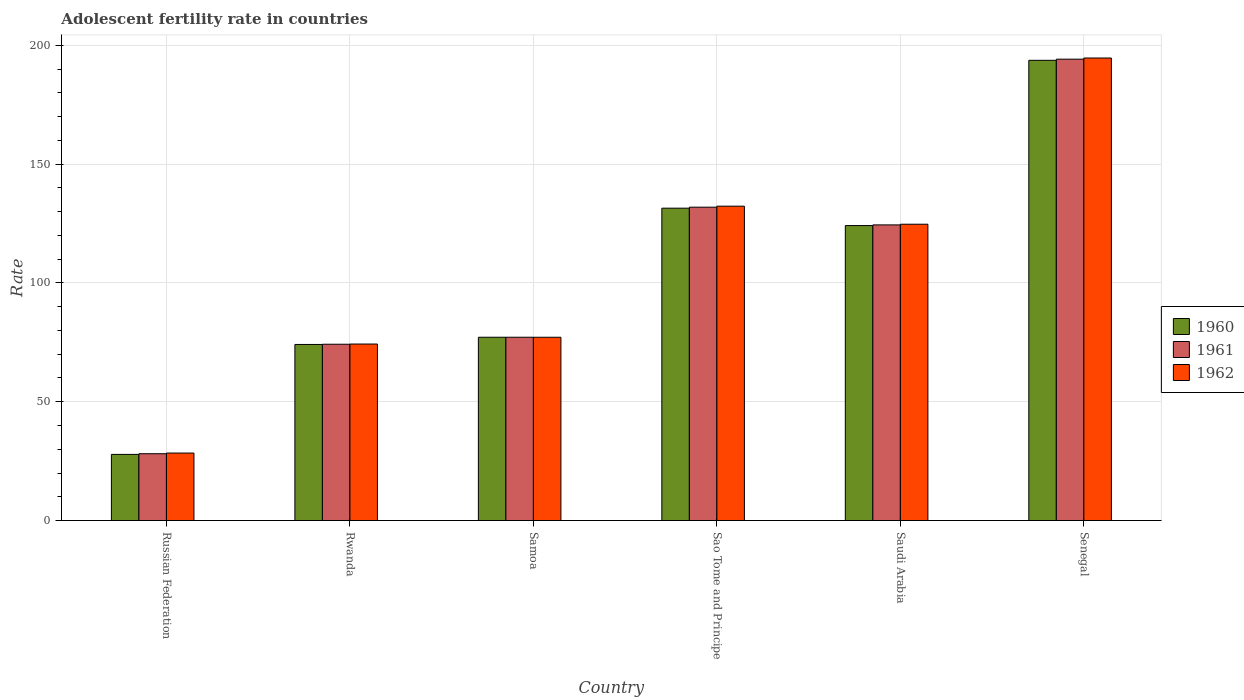How many different coloured bars are there?
Offer a very short reply. 3. Are the number of bars per tick equal to the number of legend labels?
Offer a terse response. Yes. What is the label of the 2nd group of bars from the left?
Give a very brief answer. Rwanda. In how many cases, is the number of bars for a given country not equal to the number of legend labels?
Make the answer very short. 0. What is the adolescent fertility rate in 1961 in Russian Federation?
Provide a short and direct response. 28.13. Across all countries, what is the maximum adolescent fertility rate in 1960?
Provide a succinct answer. 193.68. Across all countries, what is the minimum adolescent fertility rate in 1960?
Your answer should be compact. 27.85. In which country was the adolescent fertility rate in 1961 maximum?
Your response must be concise. Senegal. In which country was the adolescent fertility rate in 1960 minimum?
Provide a short and direct response. Russian Federation. What is the total adolescent fertility rate in 1960 in the graph?
Your answer should be very brief. 628.39. What is the difference between the adolescent fertility rate in 1962 in Samoa and that in Senegal?
Offer a very short reply. -117.51. What is the difference between the adolescent fertility rate in 1961 in Sao Tome and Principe and the adolescent fertility rate in 1960 in Saudi Arabia?
Ensure brevity in your answer.  7.74. What is the average adolescent fertility rate in 1960 per country?
Your answer should be very brief. 104.73. What is the difference between the adolescent fertility rate of/in 1961 and adolescent fertility rate of/in 1960 in Senegal?
Ensure brevity in your answer.  0.49. What is the ratio of the adolescent fertility rate in 1961 in Russian Federation to that in Samoa?
Give a very brief answer. 0.36. Is the adolescent fertility rate in 1960 in Sao Tome and Principe less than that in Senegal?
Keep it short and to the point. Yes. Is the difference between the adolescent fertility rate in 1961 in Russian Federation and Senegal greater than the difference between the adolescent fertility rate in 1960 in Russian Federation and Senegal?
Ensure brevity in your answer.  No. What is the difference between the highest and the second highest adolescent fertility rate in 1960?
Make the answer very short. 62.22. What is the difference between the highest and the lowest adolescent fertility rate in 1961?
Give a very brief answer. 166.03. What does the 3rd bar from the left in Saudi Arabia represents?
Your response must be concise. 1962. How many bars are there?
Provide a succinct answer. 18. How many countries are there in the graph?
Offer a terse response. 6. What is the difference between two consecutive major ticks on the Y-axis?
Your answer should be very brief. 50. Does the graph contain any zero values?
Your answer should be very brief. No. Where does the legend appear in the graph?
Your response must be concise. Center right. How are the legend labels stacked?
Your answer should be compact. Vertical. What is the title of the graph?
Your response must be concise. Adolescent fertility rate in countries. Does "1974" appear as one of the legend labels in the graph?
Give a very brief answer. No. What is the label or title of the X-axis?
Your answer should be very brief. Country. What is the label or title of the Y-axis?
Make the answer very short. Rate. What is the Rate of 1960 in Russian Federation?
Offer a very short reply. 27.85. What is the Rate in 1961 in Russian Federation?
Offer a terse response. 28.13. What is the Rate in 1962 in Russian Federation?
Your answer should be compact. 28.42. What is the Rate of 1960 in Rwanda?
Ensure brevity in your answer.  74.11. What is the Rate in 1961 in Rwanda?
Provide a short and direct response. 74.2. What is the Rate of 1962 in Rwanda?
Make the answer very short. 74.29. What is the Rate in 1960 in Samoa?
Offer a very short reply. 77.15. What is the Rate of 1961 in Samoa?
Your answer should be very brief. 77.15. What is the Rate of 1962 in Samoa?
Offer a terse response. 77.14. What is the Rate in 1960 in Sao Tome and Principe?
Your response must be concise. 131.46. What is the Rate in 1961 in Sao Tome and Principe?
Your response must be concise. 131.88. What is the Rate in 1962 in Sao Tome and Principe?
Offer a terse response. 132.3. What is the Rate of 1960 in Saudi Arabia?
Ensure brevity in your answer.  124.14. What is the Rate of 1961 in Saudi Arabia?
Your answer should be very brief. 124.42. What is the Rate of 1962 in Saudi Arabia?
Your answer should be very brief. 124.7. What is the Rate of 1960 in Senegal?
Your response must be concise. 193.68. What is the Rate in 1961 in Senegal?
Your response must be concise. 194.17. What is the Rate of 1962 in Senegal?
Give a very brief answer. 194.66. Across all countries, what is the maximum Rate of 1960?
Offer a terse response. 193.68. Across all countries, what is the maximum Rate of 1961?
Keep it short and to the point. 194.17. Across all countries, what is the maximum Rate of 1962?
Make the answer very short. 194.66. Across all countries, what is the minimum Rate in 1960?
Provide a succinct answer. 27.85. Across all countries, what is the minimum Rate in 1961?
Your answer should be compact. 28.13. Across all countries, what is the minimum Rate in 1962?
Your answer should be compact. 28.42. What is the total Rate of 1960 in the graph?
Make the answer very short. 628.39. What is the total Rate of 1961 in the graph?
Offer a terse response. 629.95. What is the total Rate in 1962 in the graph?
Give a very brief answer. 631.51. What is the difference between the Rate of 1960 in Russian Federation and that in Rwanda?
Ensure brevity in your answer.  -46.26. What is the difference between the Rate of 1961 in Russian Federation and that in Rwanda?
Your response must be concise. -46.07. What is the difference between the Rate in 1962 in Russian Federation and that in Rwanda?
Offer a very short reply. -45.88. What is the difference between the Rate of 1960 in Russian Federation and that in Samoa?
Your response must be concise. -49.3. What is the difference between the Rate in 1961 in Russian Federation and that in Samoa?
Offer a terse response. -49.01. What is the difference between the Rate in 1962 in Russian Federation and that in Samoa?
Offer a very short reply. -48.73. What is the difference between the Rate of 1960 in Russian Federation and that in Sao Tome and Principe?
Your answer should be compact. -103.61. What is the difference between the Rate in 1961 in Russian Federation and that in Sao Tome and Principe?
Provide a short and direct response. -103.75. What is the difference between the Rate of 1962 in Russian Federation and that in Sao Tome and Principe?
Provide a succinct answer. -103.88. What is the difference between the Rate in 1960 in Russian Federation and that in Saudi Arabia?
Offer a very short reply. -96.29. What is the difference between the Rate in 1961 in Russian Federation and that in Saudi Arabia?
Your answer should be compact. -96.29. What is the difference between the Rate of 1962 in Russian Federation and that in Saudi Arabia?
Offer a terse response. -96.29. What is the difference between the Rate in 1960 in Russian Federation and that in Senegal?
Keep it short and to the point. -165.83. What is the difference between the Rate of 1961 in Russian Federation and that in Senegal?
Offer a very short reply. -166.03. What is the difference between the Rate in 1962 in Russian Federation and that in Senegal?
Ensure brevity in your answer.  -166.24. What is the difference between the Rate in 1960 in Rwanda and that in Samoa?
Ensure brevity in your answer.  -3.04. What is the difference between the Rate in 1961 in Rwanda and that in Samoa?
Your answer should be compact. -2.94. What is the difference between the Rate of 1962 in Rwanda and that in Samoa?
Give a very brief answer. -2.85. What is the difference between the Rate of 1960 in Rwanda and that in Sao Tome and Principe?
Keep it short and to the point. -57.35. What is the difference between the Rate in 1961 in Rwanda and that in Sao Tome and Principe?
Your answer should be very brief. -57.68. What is the difference between the Rate of 1962 in Rwanda and that in Sao Tome and Principe?
Make the answer very short. -58.01. What is the difference between the Rate of 1960 in Rwanda and that in Saudi Arabia?
Offer a very short reply. -50.03. What is the difference between the Rate in 1961 in Rwanda and that in Saudi Arabia?
Give a very brief answer. -50.22. What is the difference between the Rate of 1962 in Rwanda and that in Saudi Arabia?
Provide a short and direct response. -50.41. What is the difference between the Rate in 1960 in Rwanda and that in Senegal?
Give a very brief answer. -119.57. What is the difference between the Rate of 1961 in Rwanda and that in Senegal?
Provide a short and direct response. -119.97. What is the difference between the Rate in 1962 in Rwanda and that in Senegal?
Provide a short and direct response. -120.36. What is the difference between the Rate in 1960 in Samoa and that in Sao Tome and Principe?
Offer a very short reply. -54.31. What is the difference between the Rate of 1961 in Samoa and that in Sao Tome and Principe?
Provide a succinct answer. -54.73. What is the difference between the Rate of 1962 in Samoa and that in Sao Tome and Principe?
Your answer should be compact. -55.16. What is the difference between the Rate in 1960 in Samoa and that in Saudi Arabia?
Your response must be concise. -46.99. What is the difference between the Rate in 1961 in Samoa and that in Saudi Arabia?
Keep it short and to the point. -47.28. What is the difference between the Rate of 1962 in Samoa and that in Saudi Arabia?
Keep it short and to the point. -47.56. What is the difference between the Rate of 1960 in Samoa and that in Senegal?
Keep it short and to the point. -116.53. What is the difference between the Rate of 1961 in Samoa and that in Senegal?
Keep it short and to the point. -117.02. What is the difference between the Rate in 1962 in Samoa and that in Senegal?
Make the answer very short. -117.51. What is the difference between the Rate of 1960 in Sao Tome and Principe and that in Saudi Arabia?
Give a very brief answer. 7.32. What is the difference between the Rate of 1961 in Sao Tome and Principe and that in Saudi Arabia?
Your answer should be very brief. 7.46. What is the difference between the Rate of 1962 in Sao Tome and Principe and that in Saudi Arabia?
Your answer should be compact. 7.6. What is the difference between the Rate of 1960 in Sao Tome and Principe and that in Senegal?
Your answer should be compact. -62.22. What is the difference between the Rate in 1961 in Sao Tome and Principe and that in Senegal?
Ensure brevity in your answer.  -62.29. What is the difference between the Rate of 1962 in Sao Tome and Principe and that in Senegal?
Ensure brevity in your answer.  -62.35. What is the difference between the Rate in 1960 in Saudi Arabia and that in Senegal?
Your answer should be compact. -69.54. What is the difference between the Rate of 1961 in Saudi Arabia and that in Senegal?
Provide a short and direct response. -69.75. What is the difference between the Rate in 1962 in Saudi Arabia and that in Senegal?
Offer a terse response. -69.95. What is the difference between the Rate in 1960 in Russian Federation and the Rate in 1961 in Rwanda?
Keep it short and to the point. -46.35. What is the difference between the Rate in 1960 in Russian Federation and the Rate in 1962 in Rwanda?
Provide a succinct answer. -46.44. What is the difference between the Rate in 1961 in Russian Federation and the Rate in 1962 in Rwanda?
Ensure brevity in your answer.  -46.16. What is the difference between the Rate of 1960 in Russian Federation and the Rate of 1961 in Samoa?
Make the answer very short. -49.29. What is the difference between the Rate in 1960 in Russian Federation and the Rate in 1962 in Samoa?
Make the answer very short. -49.29. What is the difference between the Rate in 1961 in Russian Federation and the Rate in 1962 in Samoa?
Your response must be concise. -49.01. What is the difference between the Rate in 1960 in Russian Federation and the Rate in 1961 in Sao Tome and Principe?
Offer a terse response. -104.03. What is the difference between the Rate of 1960 in Russian Federation and the Rate of 1962 in Sao Tome and Principe?
Offer a terse response. -104.45. What is the difference between the Rate in 1961 in Russian Federation and the Rate in 1962 in Sao Tome and Principe?
Provide a short and direct response. -104.17. What is the difference between the Rate in 1960 in Russian Federation and the Rate in 1961 in Saudi Arabia?
Your answer should be compact. -96.57. What is the difference between the Rate of 1960 in Russian Federation and the Rate of 1962 in Saudi Arabia?
Your response must be concise. -96.85. What is the difference between the Rate in 1961 in Russian Federation and the Rate in 1962 in Saudi Arabia?
Make the answer very short. -96.57. What is the difference between the Rate in 1960 in Russian Federation and the Rate in 1961 in Senegal?
Offer a terse response. -166.32. What is the difference between the Rate in 1960 in Russian Federation and the Rate in 1962 in Senegal?
Your response must be concise. -166.8. What is the difference between the Rate of 1961 in Russian Federation and the Rate of 1962 in Senegal?
Provide a short and direct response. -166.52. What is the difference between the Rate in 1960 in Rwanda and the Rate in 1961 in Samoa?
Keep it short and to the point. -3.04. What is the difference between the Rate of 1960 in Rwanda and the Rate of 1962 in Samoa?
Your answer should be very brief. -3.03. What is the difference between the Rate in 1961 in Rwanda and the Rate in 1962 in Samoa?
Your response must be concise. -2.94. What is the difference between the Rate in 1960 in Rwanda and the Rate in 1961 in Sao Tome and Principe?
Offer a very short reply. -57.77. What is the difference between the Rate of 1960 in Rwanda and the Rate of 1962 in Sao Tome and Principe?
Your answer should be very brief. -58.19. What is the difference between the Rate of 1961 in Rwanda and the Rate of 1962 in Sao Tome and Principe?
Your response must be concise. -58.1. What is the difference between the Rate in 1960 in Rwanda and the Rate in 1961 in Saudi Arabia?
Make the answer very short. -50.31. What is the difference between the Rate in 1960 in Rwanda and the Rate in 1962 in Saudi Arabia?
Provide a short and direct response. -50.59. What is the difference between the Rate in 1961 in Rwanda and the Rate in 1962 in Saudi Arabia?
Keep it short and to the point. -50.5. What is the difference between the Rate of 1960 in Rwanda and the Rate of 1961 in Senegal?
Your answer should be very brief. -120.06. What is the difference between the Rate of 1960 in Rwanda and the Rate of 1962 in Senegal?
Offer a terse response. -120.54. What is the difference between the Rate in 1961 in Rwanda and the Rate in 1962 in Senegal?
Your response must be concise. -120.45. What is the difference between the Rate of 1960 in Samoa and the Rate of 1961 in Sao Tome and Principe?
Your answer should be compact. -54.73. What is the difference between the Rate of 1960 in Samoa and the Rate of 1962 in Sao Tome and Principe?
Make the answer very short. -55.15. What is the difference between the Rate in 1961 in Samoa and the Rate in 1962 in Sao Tome and Principe?
Give a very brief answer. -55.15. What is the difference between the Rate of 1960 in Samoa and the Rate of 1961 in Saudi Arabia?
Make the answer very short. -47.27. What is the difference between the Rate of 1960 in Samoa and the Rate of 1962 in Saudi Arabia?
Ensure brevity in your answer.  -47.56. What is the difference between the Rate of 1961 in Samoa and the Rate of 1962 in Saudi Arabia?
Your answer should be compact. -47.56. What is the difference between the Rate in 1960 in Samoa and the Rate in 1961 in Senegal?
Provide a succinct answer. -117.02. What is the difference between the Rate in 1960 in Samoa and the Rate in 1962 in Senegal?
Your response must be concise. -117.51. What is the difference between the Rate in 1961 in Samoa and the Rate in 1962 in Senegal?
Ensure brevity in your answer.  -117.51. What is the difference between the Rate in 1960 in Sao Tome and Principe and the Rate in 1961 in Saudi Arabia?
Your answer should be compact. 7.04. What is the difference between the Rate of 1960 in Sao Tome and Principe and the Rate of 1962 in Saudi Arabia?
Offer a very short reply. 6.76. What is the difference between the Rate in 1961 in Sao Tome and Principe and the Rate in 1962 in Saudi Arabia?
Give a very brief answer. 7.18. What is the difference between the Rate in 1960 in Sao Tome and Principe and the Rate in 1961 in Senegal?
Offer a terse response. -62.71. What is the difference between the Rate in 1960 in Sao Tome and Principe and the Rate in 1962 in Senegal?
Provide a short and direct response. -63.2. What is the difference between the Rate in 1961 in Sao Tome and Principe and the Rate in 1962 in Senegal?
Your answer should be compact. -62.77. What is the difference between the Rate in 1960 in Saudi Arabia and the Rate in 1961 in Senegal?
Give a very brief answer. -70.03. What is the difference between the Rate in 1960 in Saudi Arabia and the Rate in 1962 in Senegal?
Your answer should be very brief. -70.51. What is the difference between the Rate of 1961 in Saudi Arabia and the Rate of 1962 in Senegal?
Provide a short and direct response. -70.23. What is the average Rate in 1960 per country?
Your response must be concise. 104.73. What is the average Rate of 1961 per country?
Keep it short and to the point. 104.99. What is the average Rate of 1962 per country?
Make the answer very short. 105.25. What is the difference between the Rate of 1960 and Rate of 1961 in Russian Federation?
Your response must be concise. -0.28. What is the difference between the Rate of 1960 and Rate of 1962 in Russian Federation?
Offer a very short reply. -0.57. What is the difference between the Rate of 1961 and Rate of 1962 in Russian Federation?
Your response must be concise. -0.28. What is the difference between the Rate in 1960 and Rate in 1961 in Rwanda?
Offer a very short reply. -0.09. What is the difference between the Rate in 1960 and Rate in 1962 in Rwanda?
Ensure brevity in your answer.  -0.18. What is the difference between the Rate in 1961 and Rate in 1962 in Rwanda?
Your answer should be very brief. -0.09. What is the difference between the Rate in 1960 and Rate in 1961 in Samoa?
Give a very brief answer. 0. What is the difference between the Rate in 1960 and Rate in 1962 in Samoa?
Provide a short and direct response. 0. What is the difference between the Rate in 1961 and Rate in 1962 in Samoa?
Offer a very short reply. 0. What is the difference between the Rate of 1960 and Rate of 1961 in Sao Tome and Principe?
Give a very brief answer. -0.42. What is the difference between the Rate in 1960 and Rate in 1962 in Sao Tome and Principe?
Your response must be concise. -0.84. What is the difference between the Rate in 1961 and Rate in 1962 in Sao Tome and Principe?
Offer a very short reply. -0.42. What is the difference between the Rate of 1960 and Rate of 1961 in Saudi Arabia?
Provide a short and direct response. -0.28. What is the difference between the Rate in 1960 and Rate in 1962 in Saudi Arabia?
Your response must be concise. -0.56. What is the difference between the Rate of 1961 and Rate of 1962 in Saudi Arabia?
Offer a very short reply. -0.28. What is the difference between the Rate of 1960 and Rate of 1961 in Senegal?
Give a very brief answer. -0.49. What is the difference between the Rate of 1960 and Rate of 1962 in Senegal?
Offer a very short reply. -0.97. What is the difference between the Rate in 1961 and Rate in 1962 in Senegal?
Offer a very short reply. -0.49. What is the ratio of the Rate in 1960 in Russian Federation to that in Rwanda?
Your response must be concise. 0.38. What is the ratio of the Rate of 1961 in Russian Federation to that in Rwanda?
Make the answer very short. 0.38. What is the ratio of the Rate in 1962 in Russian Federation to that in Rwanda?
Ensure brevity in your answer.  0.38. What is the ratio of the Rate in 1960 in Russian Federation to that in Samoa?
Ensure brevity in your answer.  0.36. What is the ratio of the Rate of 1961 in Russian Federation to that in Samoa?
Offer a terse response. 0.36. What is the ratio of the Rate in 1962 in Russian Federation to that in Samoa?
Your response must be concise. 0.37. What is the ratio of the Rate in 1960 in Russian Federation to that in Sao Tome and Principe?
Offer a terse response. 0.21. What is the ratio of the Rate of 1961 in Russian Federation to that in Sao Tome and Principe?
Your answer should be very brief. 0.21. What is the ratio of the Rate of 1962 in Russian Federation to that in Sao Tome and Principe?
Offer a terse response. 0.21. What is the ratio of the Rate of 1960 in Russian Federation to that in Saudi Arabia?
Provide a succinct answer. 0.22. What is the ratio of the Rate in 1961 in Russian Federation to that in Saudi Arabia?
Your answer should be compact. 0.23. What is the ratio of the Rate in 1962 in Russian Federation to that in Saudi Arabia?
Provide a succinct answer. 0.23. What is the ratio of the Rate in 1960 in Russian Federation to that in Senegal?
Offer a terse response. 0.14. What is the ratio of the Rate of 1961 in Russian Federation to that in Senegal?
Your answer should be very brief. 0.14. What is the ratio of the Rate in 1962 in Russian Federation to that in Senegal?
Your response must be concise. 0.15. What is the ratio of the Rate in 1960 in Rwanda to that in Samoa?
Offer a terse response. 0.96. What is the ratio of the Rate of 1961 in Rwanda to that in Samoa?
Offer a very short reply. 0.96. What is the ratio of the Rate of 1962 in Rwanda to that in Samoa?
Keep it short and to the point. 0.96. What is the ratio of the Rate of 1960 in Rwanda to that in Sao Tome and Principe?
Keep it short and to the point. 0.56. What is the ratio of the Rate in 1961 in Rwanda to that in Sao Tome and Principe?
Offer a terse response. 0.56. What is the ratio of the Rate in 1962 in Rwanda to that in Sao Tome and Principe?
Provide a succinct answer. 0.56. What is the ratio of the Rate in 1960 in Rwanda to that in Saudi Arabia?
Provide a short and direct response. 0.6. What is the ratio of the Rate of 1961 in Rwanda to that in Saudi Arabia?
Ensure brevity in your answer.  0.6. What is the ratio of the Rate of 1962 in Rwanda to that in Saudi Arabia?
Your answer should be very brief. 0.6. What is the ratio of the Rate in 1960 in Rwanda to that in Senegal?
Your answer should be compact. 0.38. What is the ratio of the Rate in 1961 in Rwanda to that in Senegal?
Keep it short and to the point. 0.38. What is the ratio of the Rate of 1962 in Rwanda to that in Senegal?
Provide a succinct answer. 0.38. What is the ratio of the Rate of 1960 in Samoa to that in Sao Tome and Principe?
Keep it short and to the point. 0.59. What is the ratio of the Rate in 1961 in Samoa to that in Sao Tome and Principe?
Your response must be concise. 0.58. What is the ratio of the Rate in 1962 in Samoa to that in Sao Tome and Principe?
Provide a succinct answer. 0.58. What is the ratio of the Rate in 1960 in Samoa to that in Saudi Arabia?
Your response must be concise. 0.62. What is the ratio of the Rate in 1961 in Samoa to that in Saudi Arabia?
Make the answer very short. 0.62. What is the ratio of the Rate of 1962 in Samoa to that in Saudi Arabia?
Give a very brief answer. 0.62. What is the ratio of the Rate of 1960 in Samoa to that in Senegal?
Offer a terse response. 0.4. What is the ratio of the Rate in 1961 in Samoa to that in Senegal?
Give a very brief answer. 0.4. What is the ratio of the Rate in 1962 in Samoa to that in Senegal?
Offer a very short reply. 0.4. What is the ratio of the Rate of 1960 in Sao Tome and Principe to that in Saudi Arabia?
Offer a very short reply. 1.06. What is the ratio of the Rate of 1961 in Sao Tome and Principe to that in Saudi Arabia?
Keep it short and to the point. 1.06. What is the ratio of the Rate in 1962 in Sao Tome and Principe to that in Saudi Arabia?
Provide a short and direct response. 1.06. What is the ratio of the Rate of 1960 in Sao Tome and Principe to that in Senegal?
Make the answer very short. 0.68. What is the ratio of the Rate of 1961 in Sao Tome and Principe to that in Senegal?
Give a very brief answer. 0.68. What is the ratio of the Rate of 1962 in Sao Tome and Principe to that in Senegal?
Your answer should be compact. 0.68. What is the ratio of the Rate in 1960 in Saudi Arabia to that in Senegal?
Provide a short and direct response. 0.64. What is the ratio of the Rate in 1961 in Saudi Arabia to that in Senegal?
Offer a terse response. 0.64. What is the ratio of the Rate in 1962 in Saudi Arabia to that in Senegal?
Ensure brevity in your answer.  0.64. What is the difference between the highest and the second highest Rate in 1960?
Provide a succinct answer. 62.22. What is the difference between the highest and the second highest Rate of 1961?
Make the answer very short. 62.29. What is the difference between the highest and the second highest Rate in 1962?
Offer a terse response. 62.35. What is the difference between the highest and the lowest Rate in 1960?
Your response must be concise. 165.83. What is the difference between the highest and the lowest Rate of 1961?
Your answer should be compact. 166.03. What is the difference between the highest and the lowest Rate of 1962?
Your answer should be compact. 166.24. 